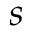Convert formula to latex. <formula><loc_0><loc_0><loc_500><loc_500>s</formula> 